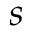Convert formula to latex. <formula><loc_0><loc_0><loc_500><loc_500>s</formula> 